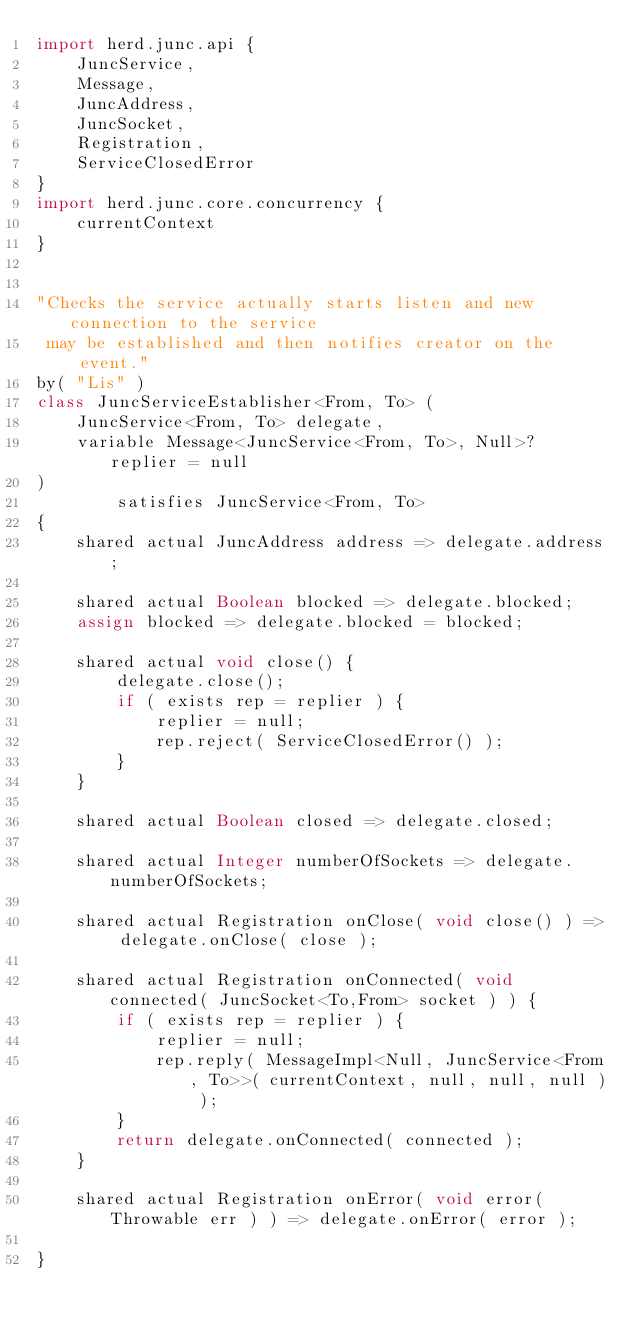Convert code to text. <code><loc_0><loc_0><loc_500><loc_500><_Ceylon_>import herd.junc.api {
	JuncService,
	Message,
	JuncAddress,
	JuncSocket,
	Registration,
	ServiceClosedError
}
import herd.junc.core.concurrency {
	currentContext
}


"Checks the service actually starts listen and new connection to the service
 may be established and then notifies creator on the event."
by( "Lis" )
class JuncServiceEstablisher<From, To> (
	JuncService<From, To> delegate,
	variable Message<JuncService<From, To>, Null>? replier = null
)
		satisfies JuncService<From, To>
{
	shared actual JuncAddress address => delegate.address;
	
	shared actual Boolean blocked => delegate.blocked;
	assign blocked => delegate.blocked = blocked;
	
	shared actual void close() {
		delegate.close();
		if ( exists rep = replier ) {
			replier = null;
			rep.reject( ServiceClosedError() );
		}
	}
	
	shared actual Boolean closed => delegate.closed;
	
	shared actual Integer numberOfSockets => delegate.numberOfSockets;
	
	shared actual Registration onClose( void close() ) => delegate.onClose( close );
	
	shared actual Registration onConnected( void connected( JuncSocket<To,From> socket ) ) {
		if ( exists rep = replier ) {
			replier = null;
			rep.reply( MessageImpl<Null, JuncService<From, To>>( currentContext, null, null, null ) );
		}
		return delegate.onConnected( connected );
	}
	
	shared actual Registration onError( void error( Throwable err ) ) => delegate.onError( error );
	
}
</code> 